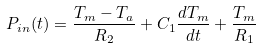Convert formula to latex. <formula><loc_0><loc_0><loc_500><loc_500>P _ { i n } ( t ) = \frac { T _ { m } - T _ { a } } { R _ { 2 } } + C _ { 1 } \frac { d T _ { m } } { d t } + \frac { T _ { m } } { R _ { 1 } }</formula> 